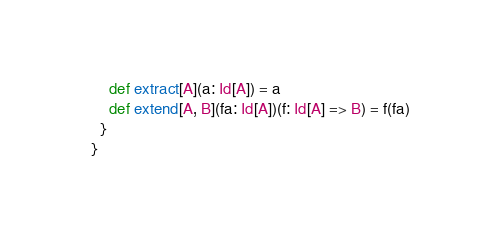Convert code to text. <code><loc_0><loc_0><loc_500><loc_500><_Scala_>    def extract[A](a: Id[A]) = a
    def extend[A, B](fa: Id[A])(f: Id[A] => B) = f(fa)
  }
}
</code> 